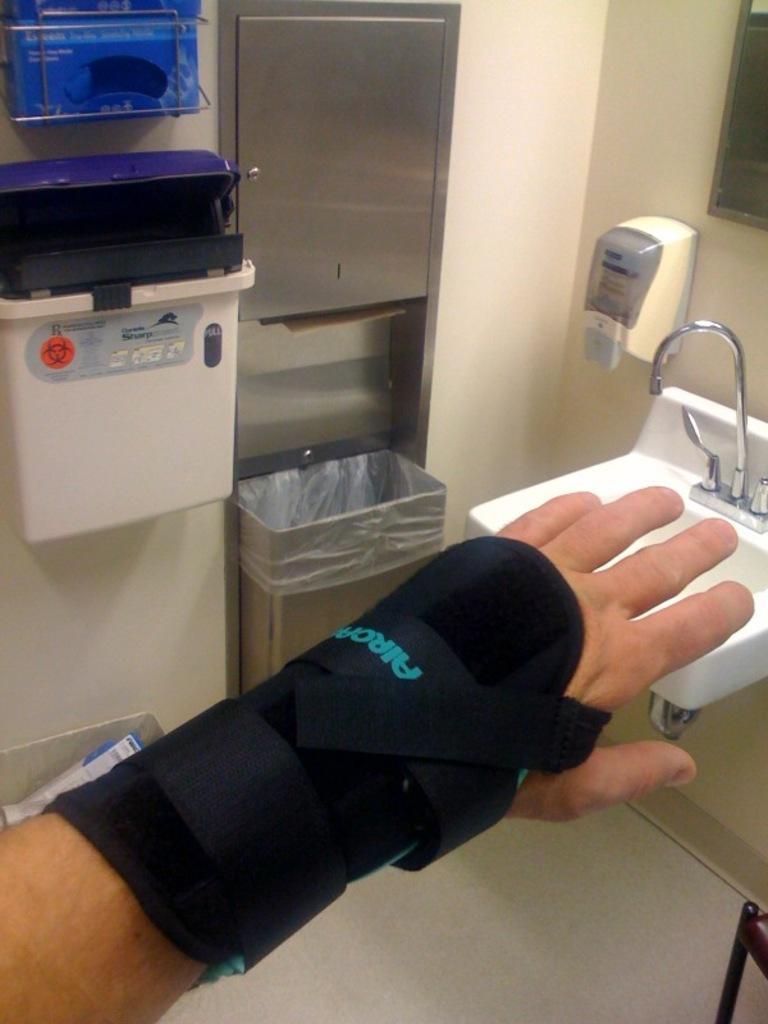Please provide a concise description of this image. In this image I can see the sink and tap to the right. I can also see the soap dispenser to the side. To the left I can see the box which is in white color. To the side I can see the dustbin. There is a person's hand and the black color band to it. 